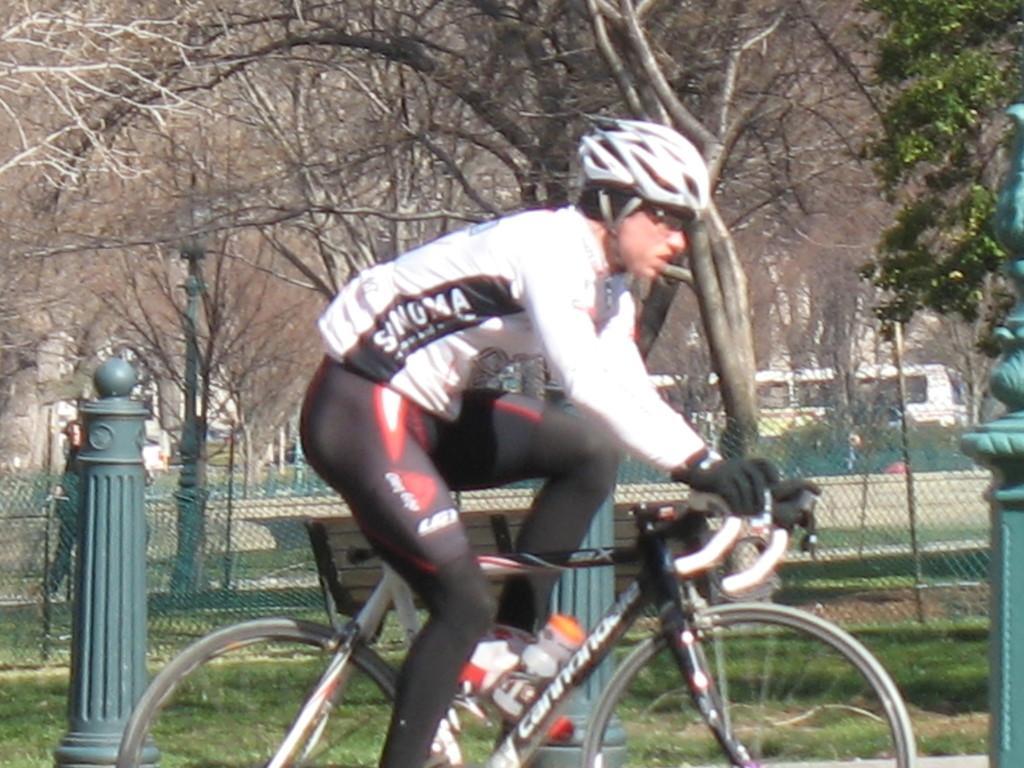Describe this image in one or two sentences. The man is riding bicycle. He is wearing helmet on his head and also spectacles. He is wearing white color jacket and black color pant. He is carrying water bottle in bicycle. Behind him, we find a bench and also a rod. Behind this rod, a man or a person is walking over there. We can see fence here and beside these fence we find trees and also bus is moving over there. 